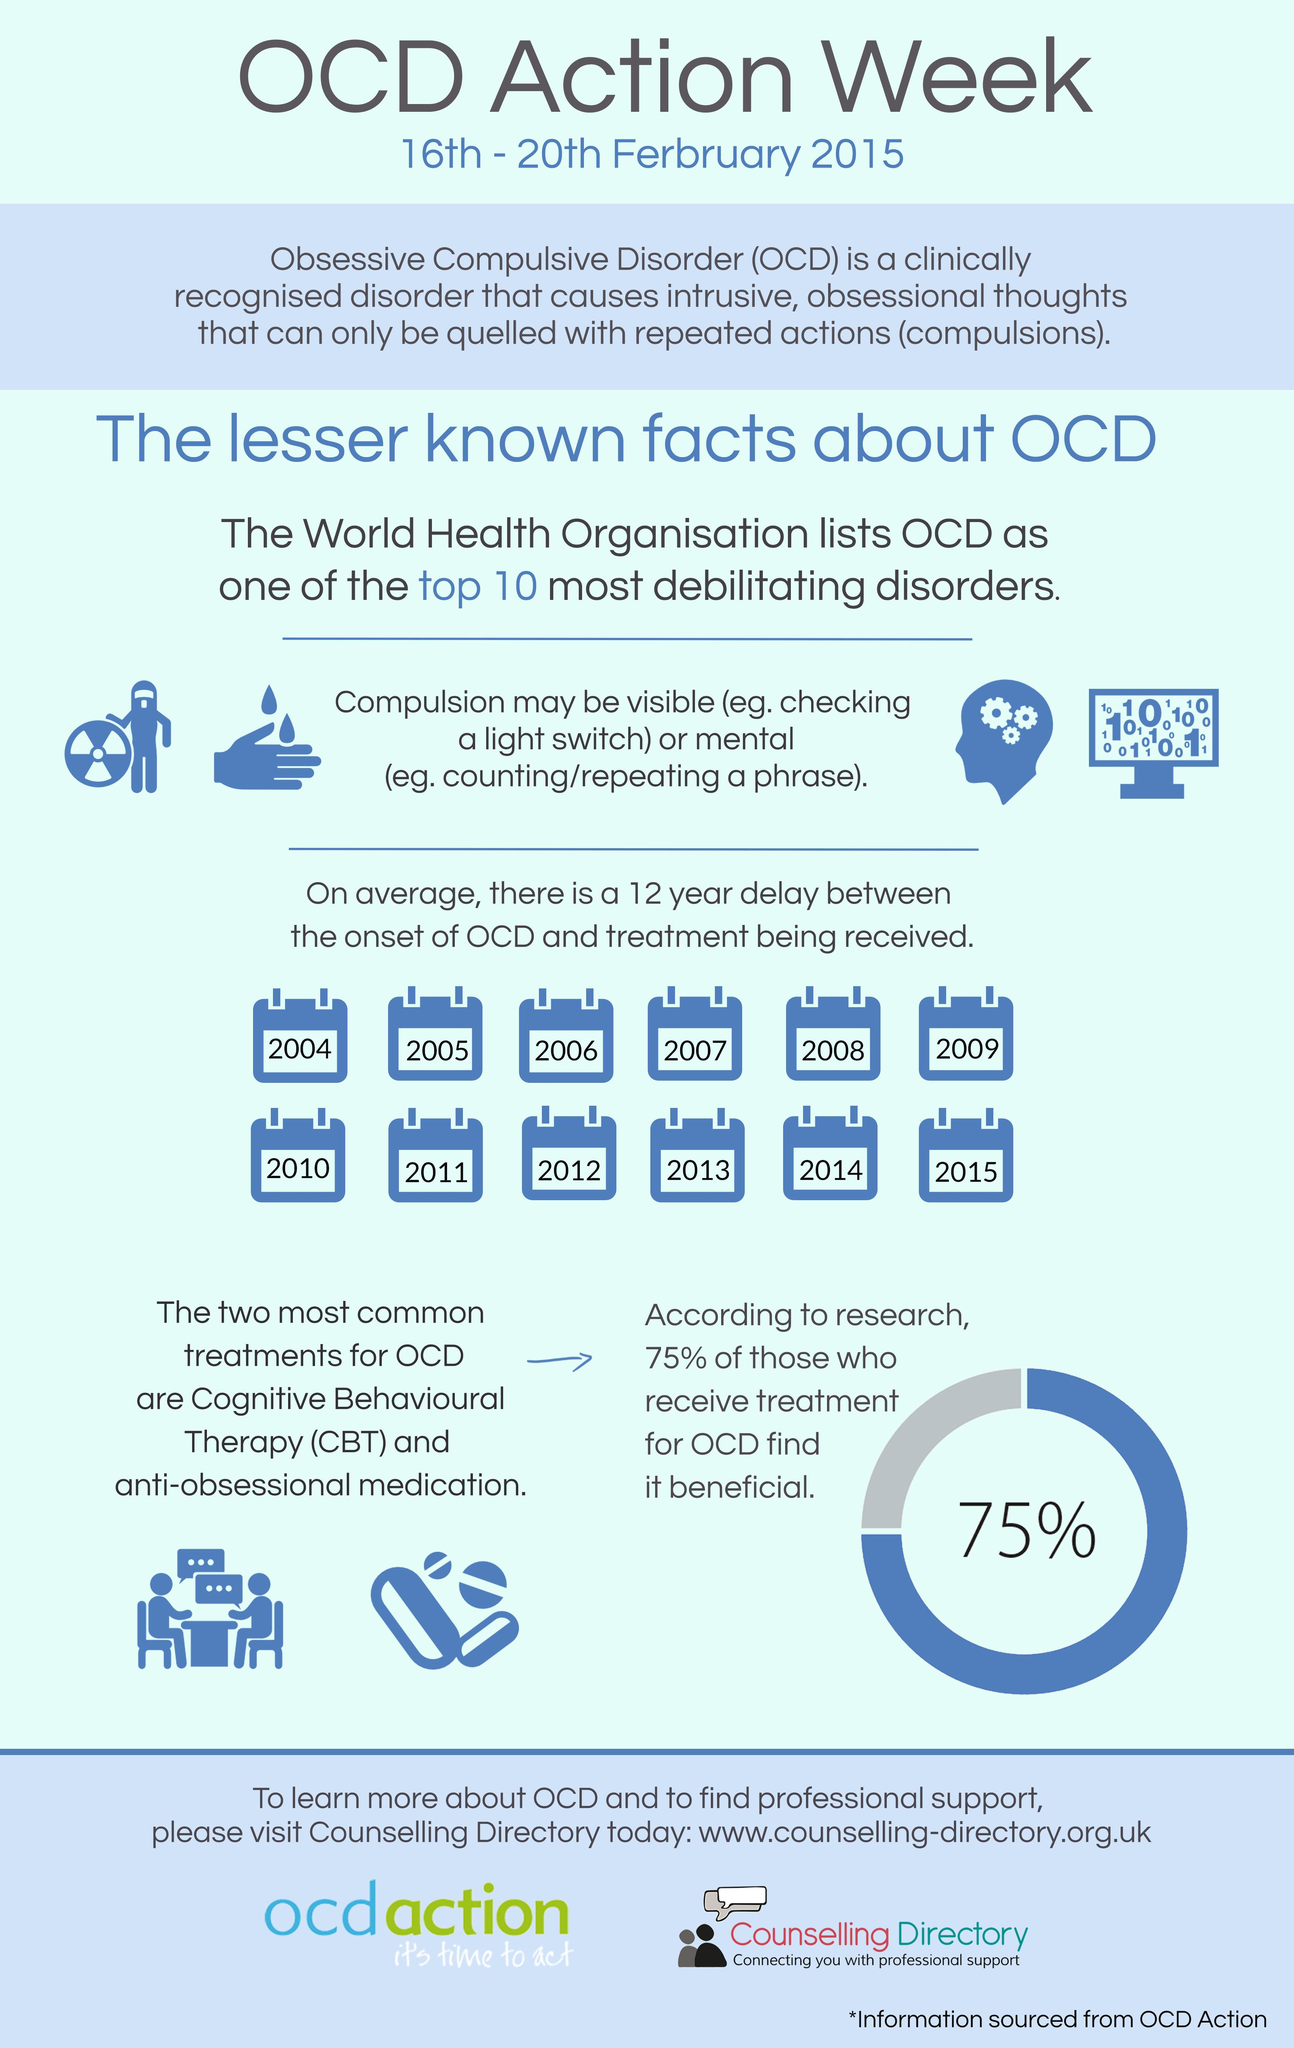List a handful of essential elements in this visual. The treatment methods for Obsessive Compulsive Disorder (OCD) are Cognitive Behavioural Therapy (CBT) and medication that is anti-obsessional in nature. Approximately 25% of individuals with Obsessive-Compulsive Disorder (OCD) have not experienced significant improvement from treatment, according to recent studies. It is estimated that treatment for Obsessive-Compulsive Disorder (OCD) has been helpful for approximately 75% of people with the condition. 